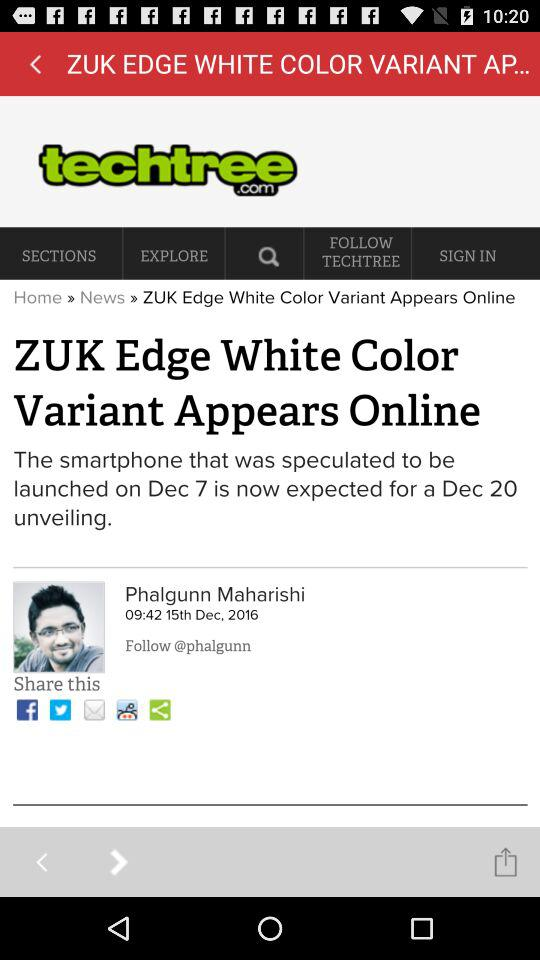How many notifications are there in "SIGN IN"?
When the provided information is insufficient, respond with <no answer>. <no answer> 